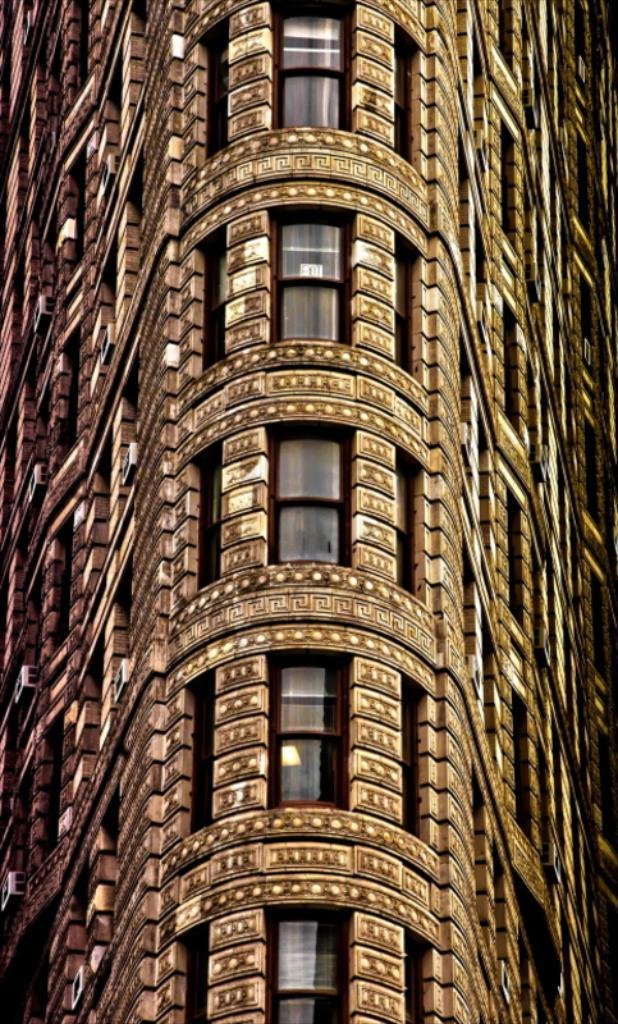What type of structure is present in the image? There is a building in the image. Can you describe the color of the building? The building is brown in color. How many dolls are sitting on the roof of the brown building in the image? There are no dolls present in the image, and the image does not show the roof of the building. 